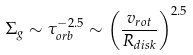Convert formula to latex. <formula><loc_0><loc_0><loc_500><loc_500>\Sigma _ { g } \sim \tau _ { o r b } ^ { - 2 . 5 } \sim \left ( \frac { v _ { r o t } } { R _ { d i s k } } \right ) ^ { 2 . 5 }</formula> 